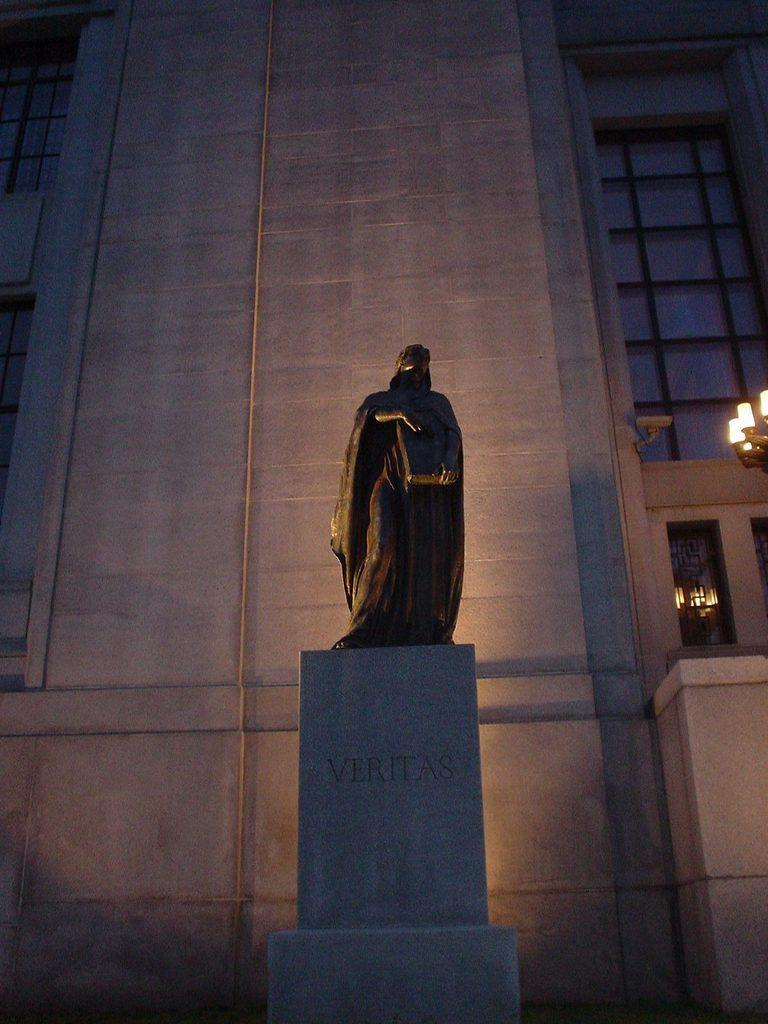What is the main structure visible in the image? There is a building in the image. What feature can be seen on the building? The building has windows. Can you see a zipper on the building in the image? No, there is no zipper present on the building in the image. 